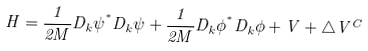Convert formula to latex. <formula><loc_0><loc_0><loc_500><loc_500>H = \frac { 1 } { 2 M } D _ { k } \psi ^ { ^ { * } } D _ { k } \psi + \frac { 1 } { 2 M } D _ { k } \phi ^ { ^ { * } } D _ { k } \phi + V + \triangle V ^ { C }</formula> 